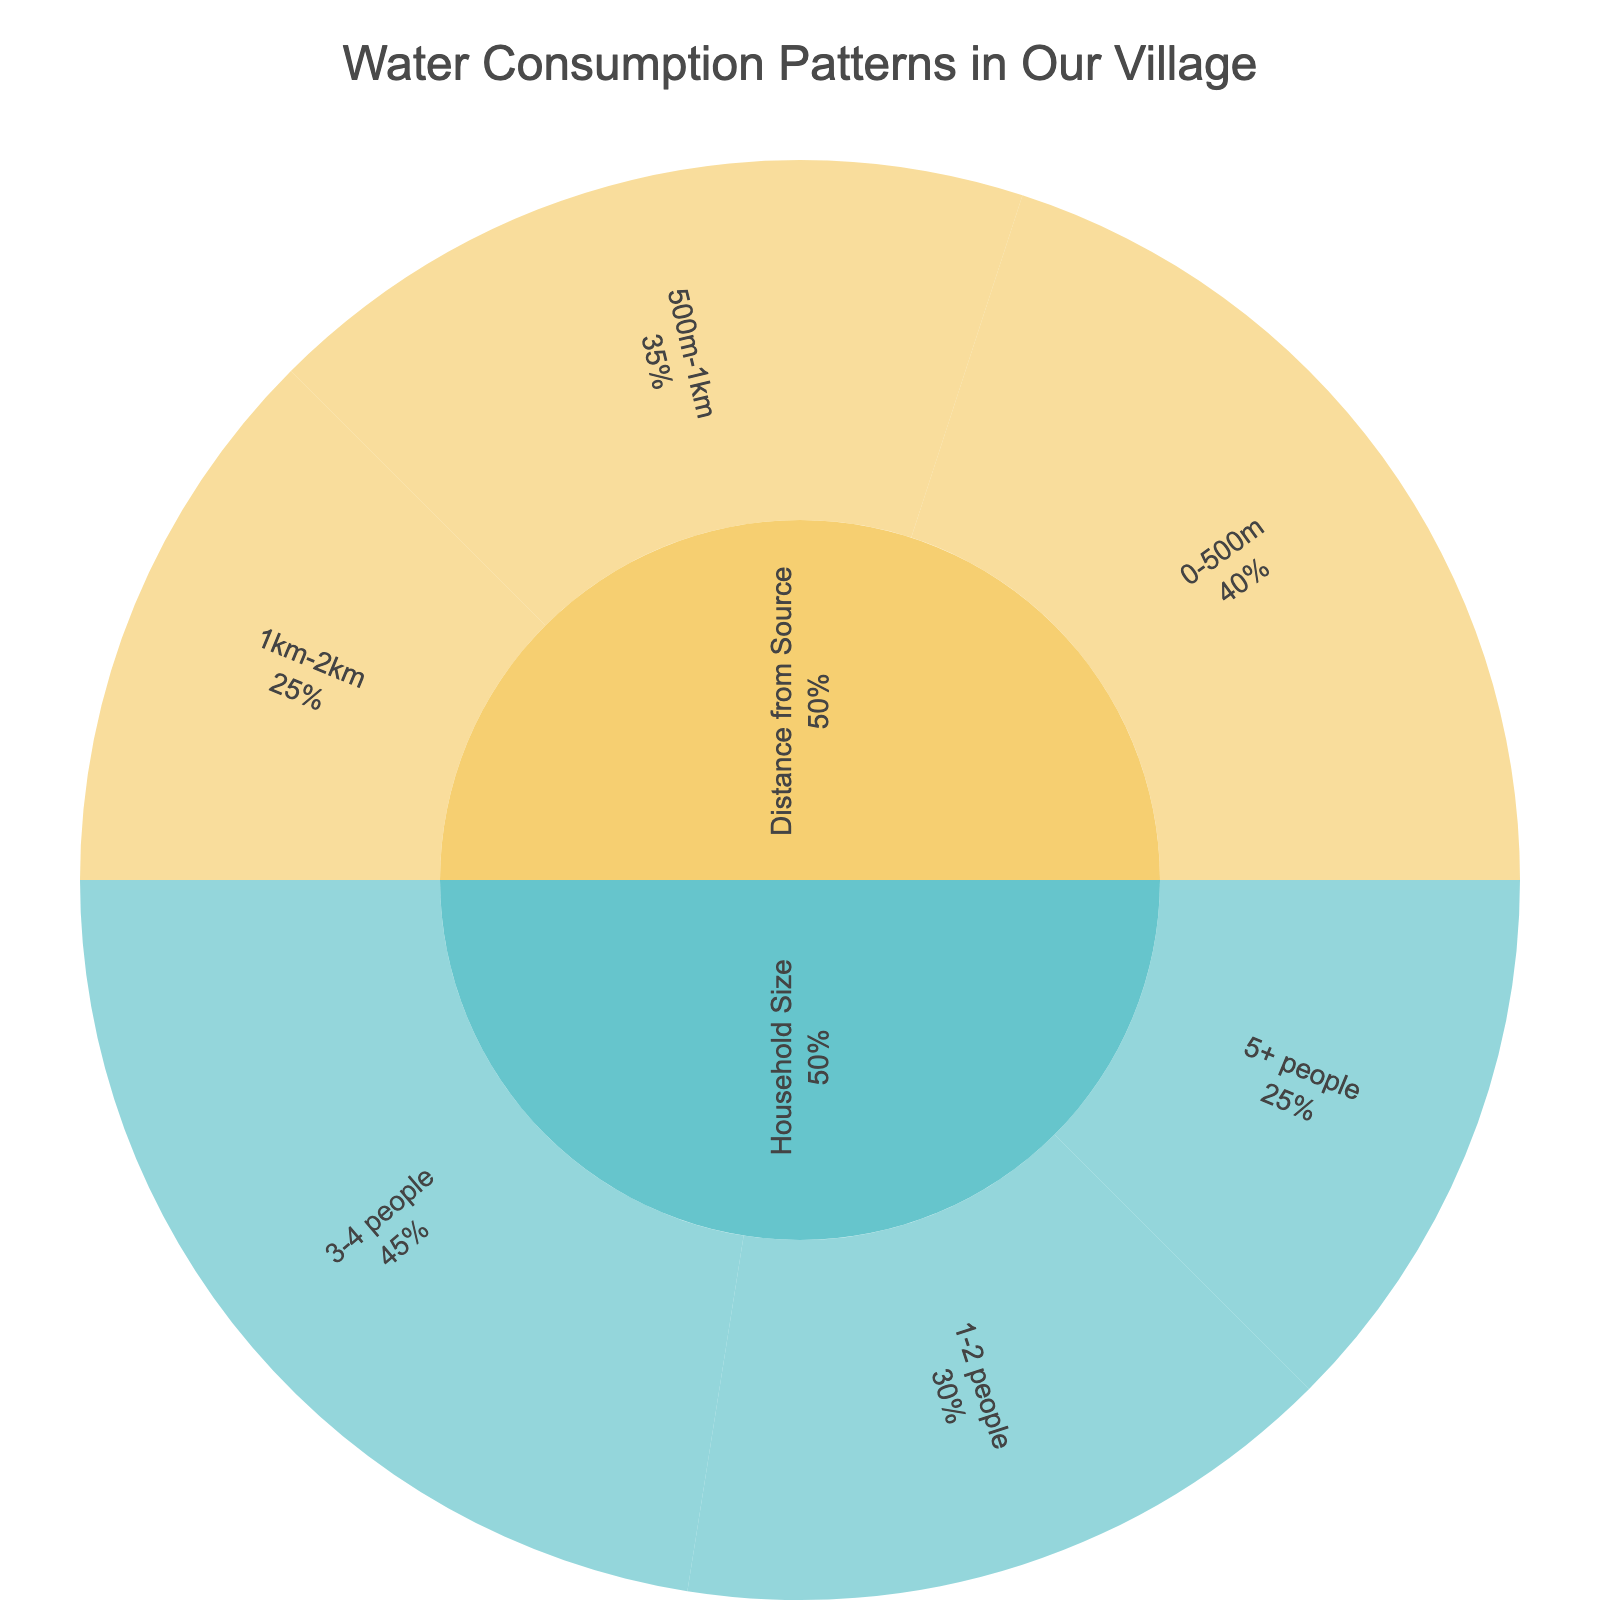What is the title of the chart? The title is displayed at the top center of the chart and often summarizes the main focus of the data visualization.
Answer: Water Consumption Patterns in Our Village Which household size has the highest water consumption? The subcategories under 'Household Size' are colored and sized differently, indicating their share in the overall consumption. The largest section corresponds to the '3-4 people' category.
Answer: 3-4 people What is the combined water consumption of households sized 1-2 people and 5+ people? Find the values for '1-2 people' (30) and '5+ people' (25), and then add them together: 30 + 25 = 55.
Answer: 55 units How does the water consumption of households within 0-500m compare to those within 500m-1km? The values for '0-500m' and '500m-1km' are 40 and 35 respectively. 40 is greater than 35, hence households within 0-500m consume more water.
Answer: 0-500m > 500m-1km What percentage of the total water consumption is from households sized 3-4 people? From the data, '3-4 people' category has 45 out of a total of 125 (sum of all values: 30 + 45 + 25 + 40 + 35 + 25). The percentage is (45/125) * 100 = 36%.
Answer: 36% What is the difference in water consumption between the '3-4 people' category and '5+ people' category? To find the difference, subtract the value of the '5+ people' category (25) from the '3-4 people' category (45): 45 - 25 = 20.
Answer: 20 units Which distance category has the lowest water consumption? Comparing the values for each distance category, '1km-2km' has the lowest value of 25 units.
Answer: 1km-2km How much more water do households within 0-500m consume compared to those within 1km-2km? Find the values for '0-500m' (40) and '1km-2km' (25), and then subtract: 40 - 25 = 15.
Answer: 15 units Are the categories and subcategories distinguished in any specific way on the chart? Categories and subcategories are visually distinguished using different colors (from the Pastel color sequence) and hierarchical placement.
Answer: Yes What's the total water consumption covered in this chart? Sum all the values from each subcategory: 30 + 45 + 25 + 40 + 35 + 25 = 200.
Answer: 200 units 